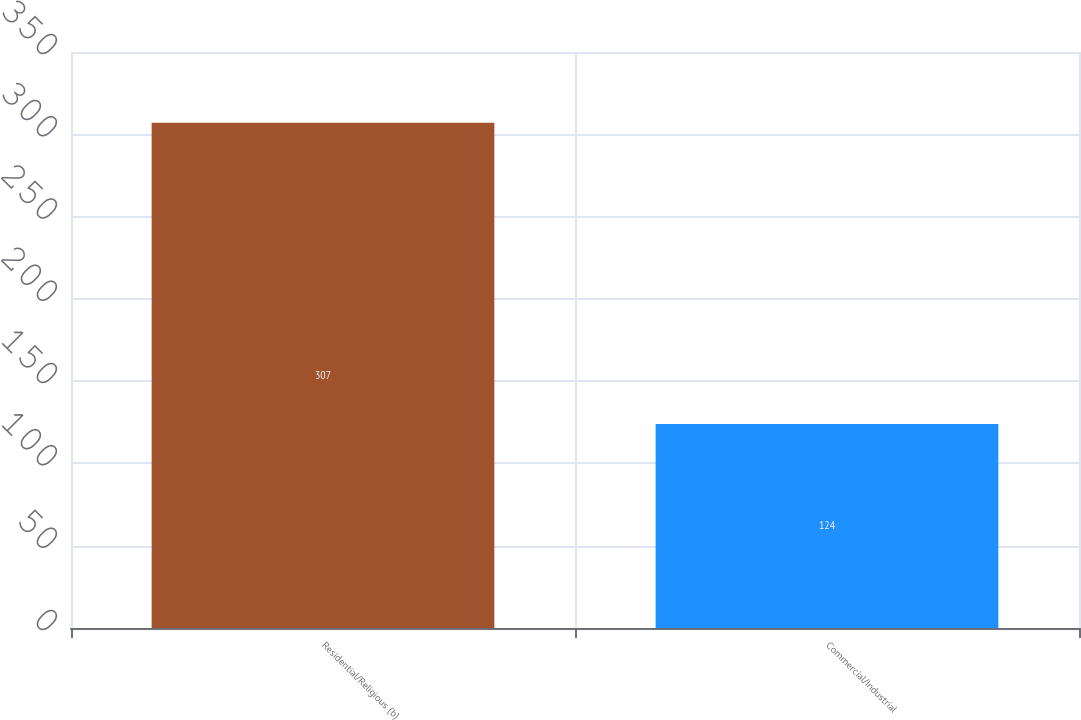Convert chart. <chart><loc_0><loc_0><loc_500><loc_500><bar_chart><fcel>Residential/Religious (b)<fcel>Commercial/Industrial<nl><fcel>307<fcel>124<nl></chart> 